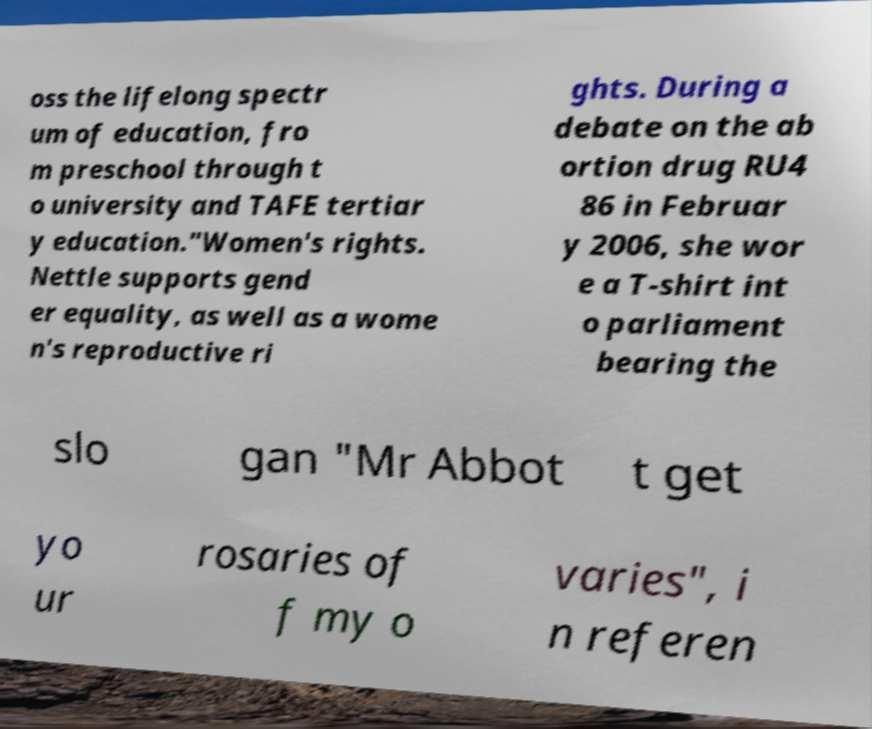Please identify and transcribe the text found in this image. oss the lifelong spectr um of education, fro m preschool through t o university and TAFE tertiar y education."Women's rights. Nettle supports gend er equality, as well as a wome n's reproductive ri ghts. During a debate on the ab ortion drug RU4 86 in Februar y 2006, she wor e a T-shirt int o parliament bearing the slo gan "Mr Abbot t get yo ur rosaries of f my o varies", i n referen 